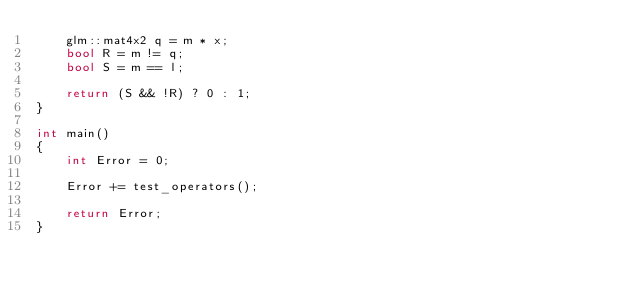<code> <loc_0><loc_0><loc_500><loc_500><_C++_>	glm::mat4x2 q = m * x;
	bool R = m != q;
	bool S = m == l;

	return (S && !R) ? 0 : 1;
}

int main()
{
	int Error = 0;

	Error += test_operators();

	return Error;
}

</code> 